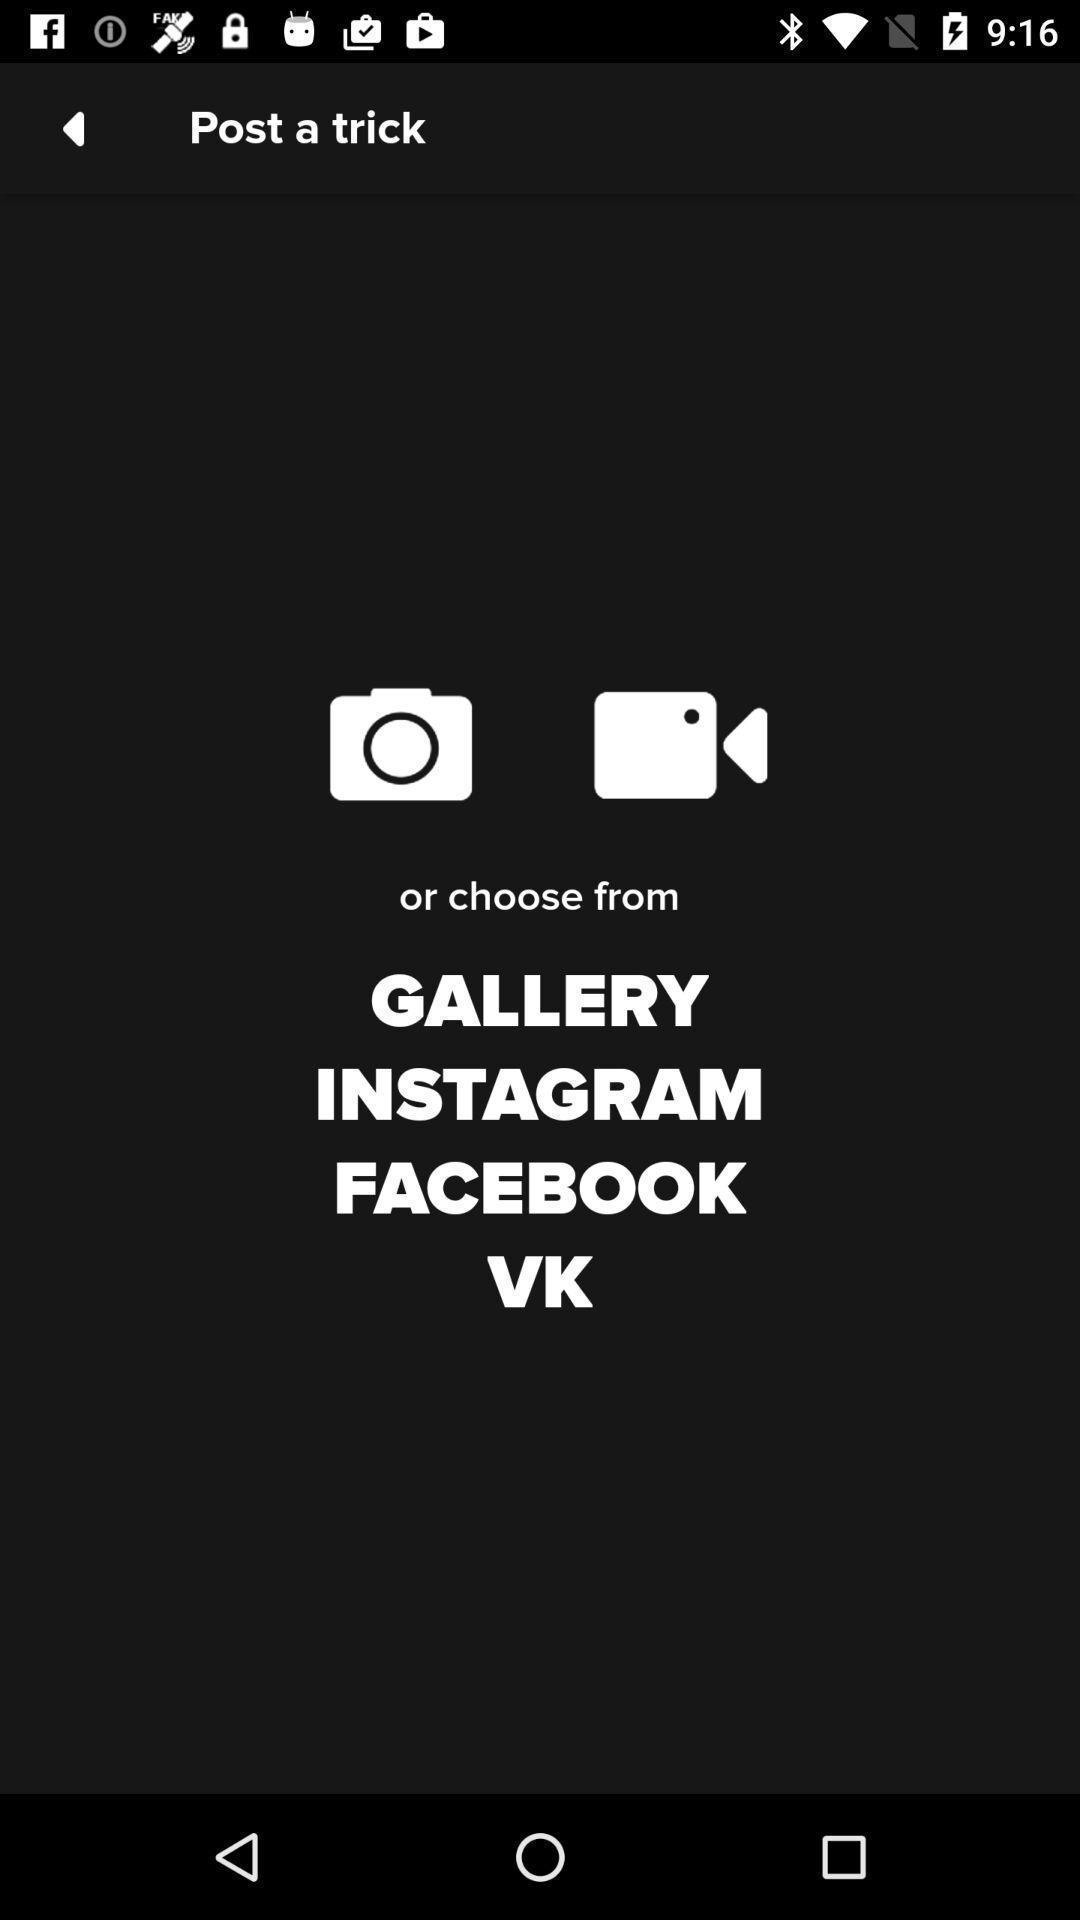Explain the elements present in this screenshot. Page for posting a trick through different apps. 